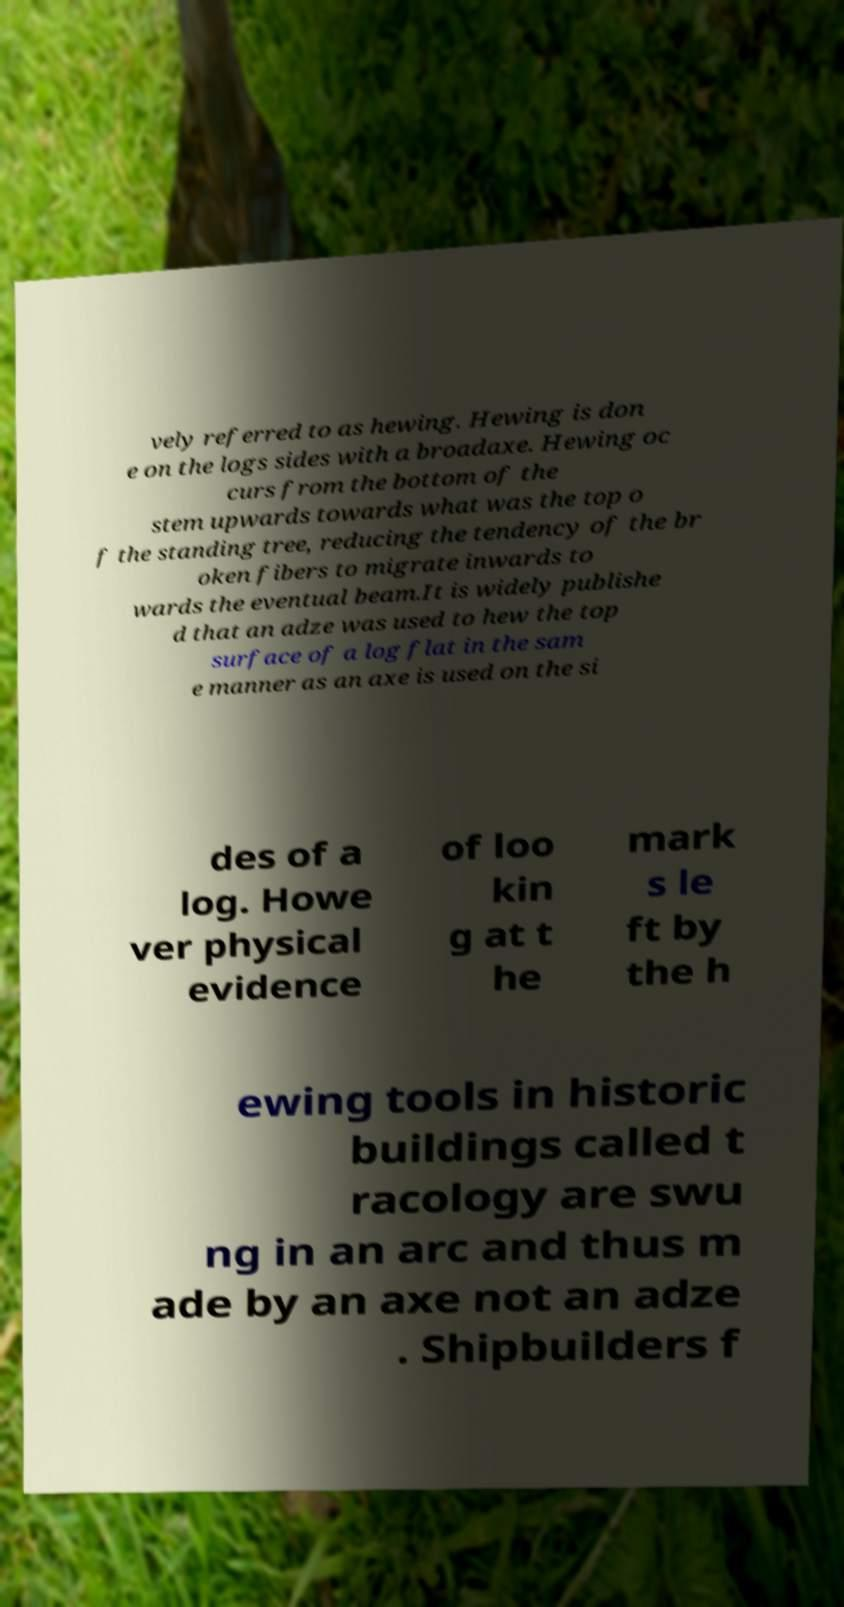For documentation purposes, I need the text within this image transcribed. Could you provide that? vely referred to as hewing. Hewing is don e on the logs sides with a broadaxe. Hewing oc curs from the bottom of the stem upwards towards what was the top o f the standing tree, reducing the tendency of the br oken fibers to migrate inwards to wards the eventual beam.It is widely publishe d that an adze was used to hew the top surface of a log flat in the sam e manner as an axe is used on the si des of a log. Howe ver physical evidence of loo kin g at t he mark s le ft by the h ewing tools in historic buildings called t racology are swu ng in an arc and thus m ade by an axe not an adze . Shipbuilders f 